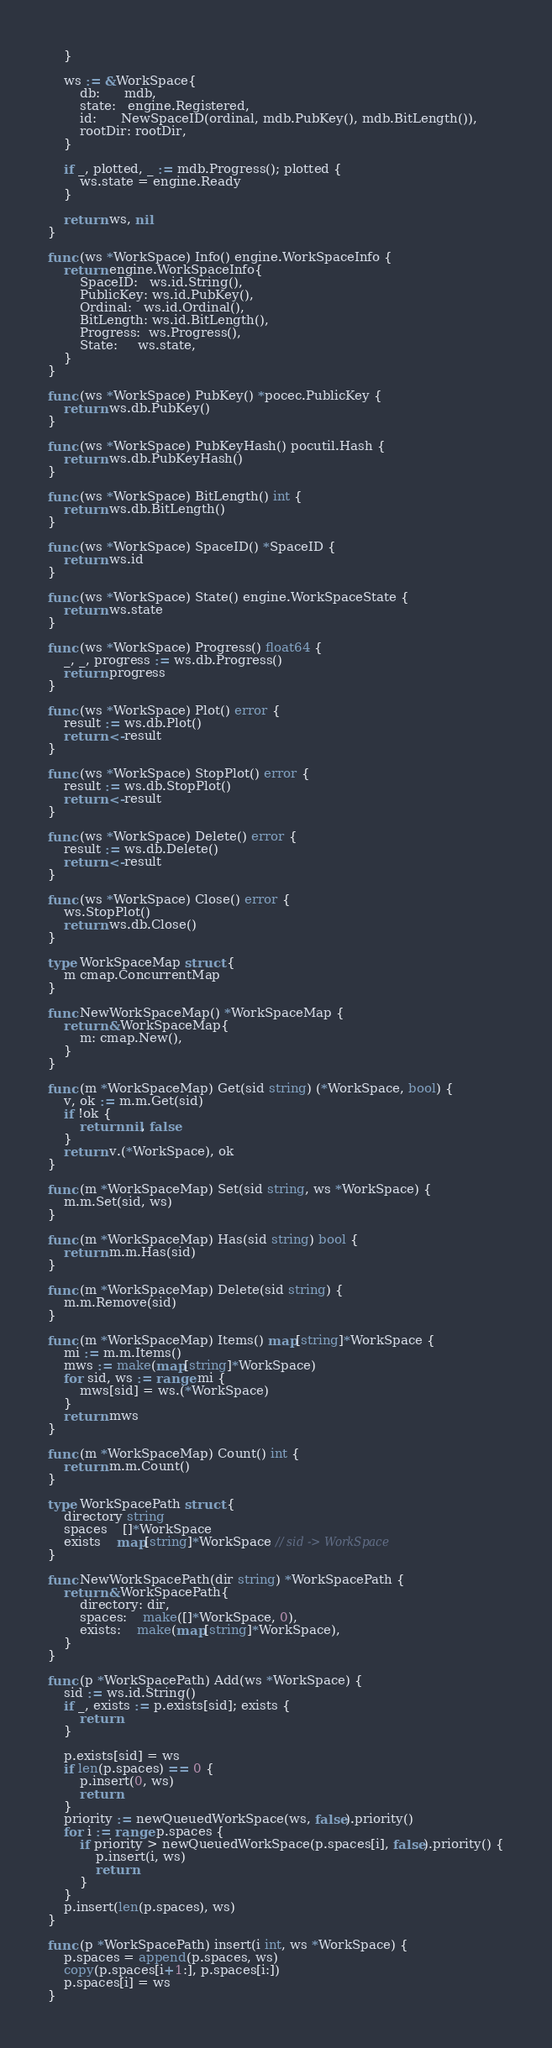<code> <loc_0><loc_0><loc_500><loc_500><_Go_>	}

	ws := &WorkSpace{
		db:      mdb,
		state:   engine.Registered,
		id:      NewSpaceID(ordinal, mdb.PubKey(), mdb.BitLength()),
		rootDir: rootDir,
	}

	if _, plotted, _ := mdb.Progress(); plotted {
		ws.state = engine.Ready
	}

	return ws, nil
}

func (ws *WorkSpace) Info() engine.WorkSpaceInfo {
	return engine.WorkSpaceInfo{
		SpaceID:   ws.id.String(),
		PublicKey: ws.id.PubKey(),
		Ordinal:   ws.id.Ordinal(),
		BitLength: ws.id.BitLength(),
		Progress:  ws.Progress(),
		State:     ws.state,
	}
}

func (ws *WorkSpace) PubKey() *pocec.PublicKey {
	return ws.db.PubKey()
}

func (ws *WorkSpace) PubKeyHash() pocutil.Hash {
	return ws.db.PubKeyHash()
}

func (ws *WorkSpace) BitLength() int {
	return ws.db.BitLength()
}

func (ws *WorkSpace) SpaceID() *SpaceID {
	return ws.id
}

func (ws *WorkSpace) State() engine.WorkSpaceState {
	return ws.state
}

func (ws *WorkSpace) Progress() float64 {
	_, _, progress := ws.db.Progress()
	return progress
}

func (ws *WorkSpace) Plot() error {
	result := ws.db.Plot()
	return <-result
}

func (ws *WorkSpace) StopPlot() error {
	result := ws.db.StopPlot()
	return <-result
}

func (ws *WorkSpace) Delete() error {
	result := ws.db.Delete()
	return <-result
}

func (ws *WorkSpace) Close() error {
	ws.StopPlot()
	return ws.db.Close()
}

type WorkSpaceMap struct {
	m cmap.ConcurrentMap
}

func NewWorkSpaceMap() *WorkSpaceMap {
	return &WorkSpaceMap{
		m: cmap.New(),
	}
}

func (m *WorkSpaceMap) Get(sid string) (*WorkSpace, bool) {
	v, ok := m.m.Get(sid)
	if !ok {
		return nil, false
	}
	return v.(*WorkSpace), ok
}

func (m *WorkSpaceMap) Set(sid string, ws *WorkSpace) {
	m.m.Set(sid, ws)
}

func (m *WorkSpaceMap) Has(sid string) bool {
	return m.m.Has(sid)
}

func (m *WorkSpaceMap) Delete(sid string) {
	m.m.Remove(sid)
}

func (m *WorkSpaceMap) Items() map[string]*WorkSpace {
	mi := m.m.Items()
	mws := make(map[string]*WorkSpace)
	for sid, ws := range mi {
		mws[sid] = ws.(*WorkSpace)
	}
	return mws
}

func (m *WorkSpaceMap) Count() int {
	return m.m.Count()
}

type WorkSpacePath struct {
	directory string
	spaces    []*WorkSpace
	exists    map[string]*WorkSpace // sid -> WorkSpace
}

func NewWorkSpacePath(dir string) *WorkSpacePath {
	return &WorkSpacePath{
		directory: dir,
		spaces:    make([]*WorkSpace, 0),
		exists:    make(map[string]*WorkSpace),
	}
}

func (p *WorkSpacePath) Add(ws *WorkSpace) {
	sid := ws.id.String()
	if _, exists := p.exists[sid]; exists {
		return
	}

	p.exists[sid] = ws
	if len(p.spaces) == 0 {
		p.insert(0, ws)
		return
	}
	priority := newQueuedWorkSpace(ws, false).priority()
	for i := range p.spaces {
		if priority > newQueuedWorkSpace(p.spaces[i], false).priority() {
			p.insert(i, ws)
			return
		}
	}
	p.insert(len(p.spaces), ws)
}

func (p *WorkSpacePath) insert(i int, ws *WorkSpace) {
	p.spaces = append(p.spaces, ws)
	copy(p.spaces[i+1:], p.spaces[i:])
	p.spaces[i] = ws
}
</code> 